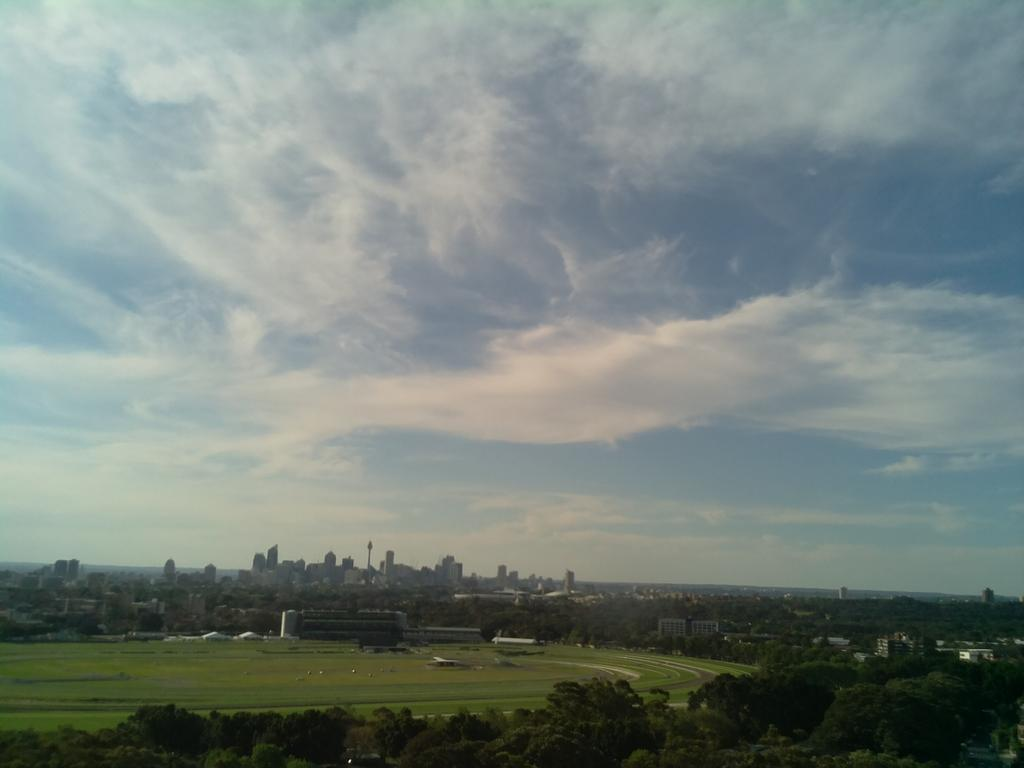What type of vegetation can be seen in the image? There are trees in the image. What structures are visible in the background of the image? There are buildings in the background of the image. What type of ground cover is visible in the image? There is grass visible in the image. What is visible at the top of the image? The sky is visible at the top of the image. What month is it in the image? The month cannot be determined from the image, as it does not contain any information about the time of year. Can you tell me how many bells are present in the image? There are no bells visible in the image. 